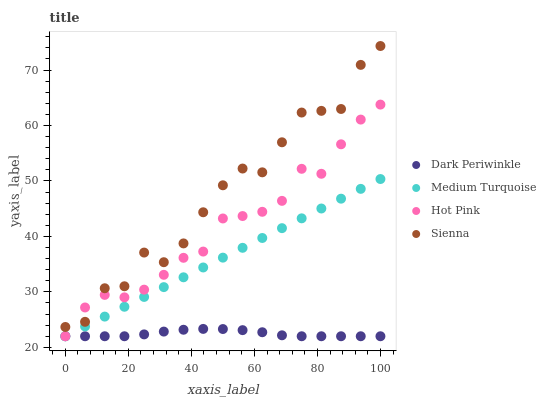Does Dark Periwinkle have the minimum area under the curve?
Answer yes or no. Yes. Does Sienna have the maximum area under the curve?
Answer yes or no. Yes. Does Hot Pink have the minimum area under the curve?
Answer yes or no. No. Does Hot Pink have the maximum area under the curve?
Answer yes or no. No. Is Medium Turquoise the smoothest?
Answer yes or no. Yes. Is Sienna the roughest?
Answer yes or no. Yes. Is Hot Pink the smoothest?
Answer yes or no. No. Is Hot Pink the roughest?
Answer yes or no. No. Does Hot Pink have the lowest value?
Answer yes or no. Yes. Does Sienna have the highest value?
Answer yes or no. Yes. Does Hot Pink have the highest value?
Answer yes or no. No. Is Dark Periwinkle less than Sienna?
Answer yes or no. Yes. Is Sienna greater than Medium Turquoise?
Answer yes or no. Yes. Does Medium Turquoise intersect Dark Periwinkle?
Answer yes or no. Yes. Is Medium Turquoise less than Dark Periwinkle?
Answer yes or no. No. Is Medium Turquoise greater than Dark Periwinkle?
Answer yes or no. No. Does Dark Periwinkle intersect Sienna?
Answer yes or no. No. 